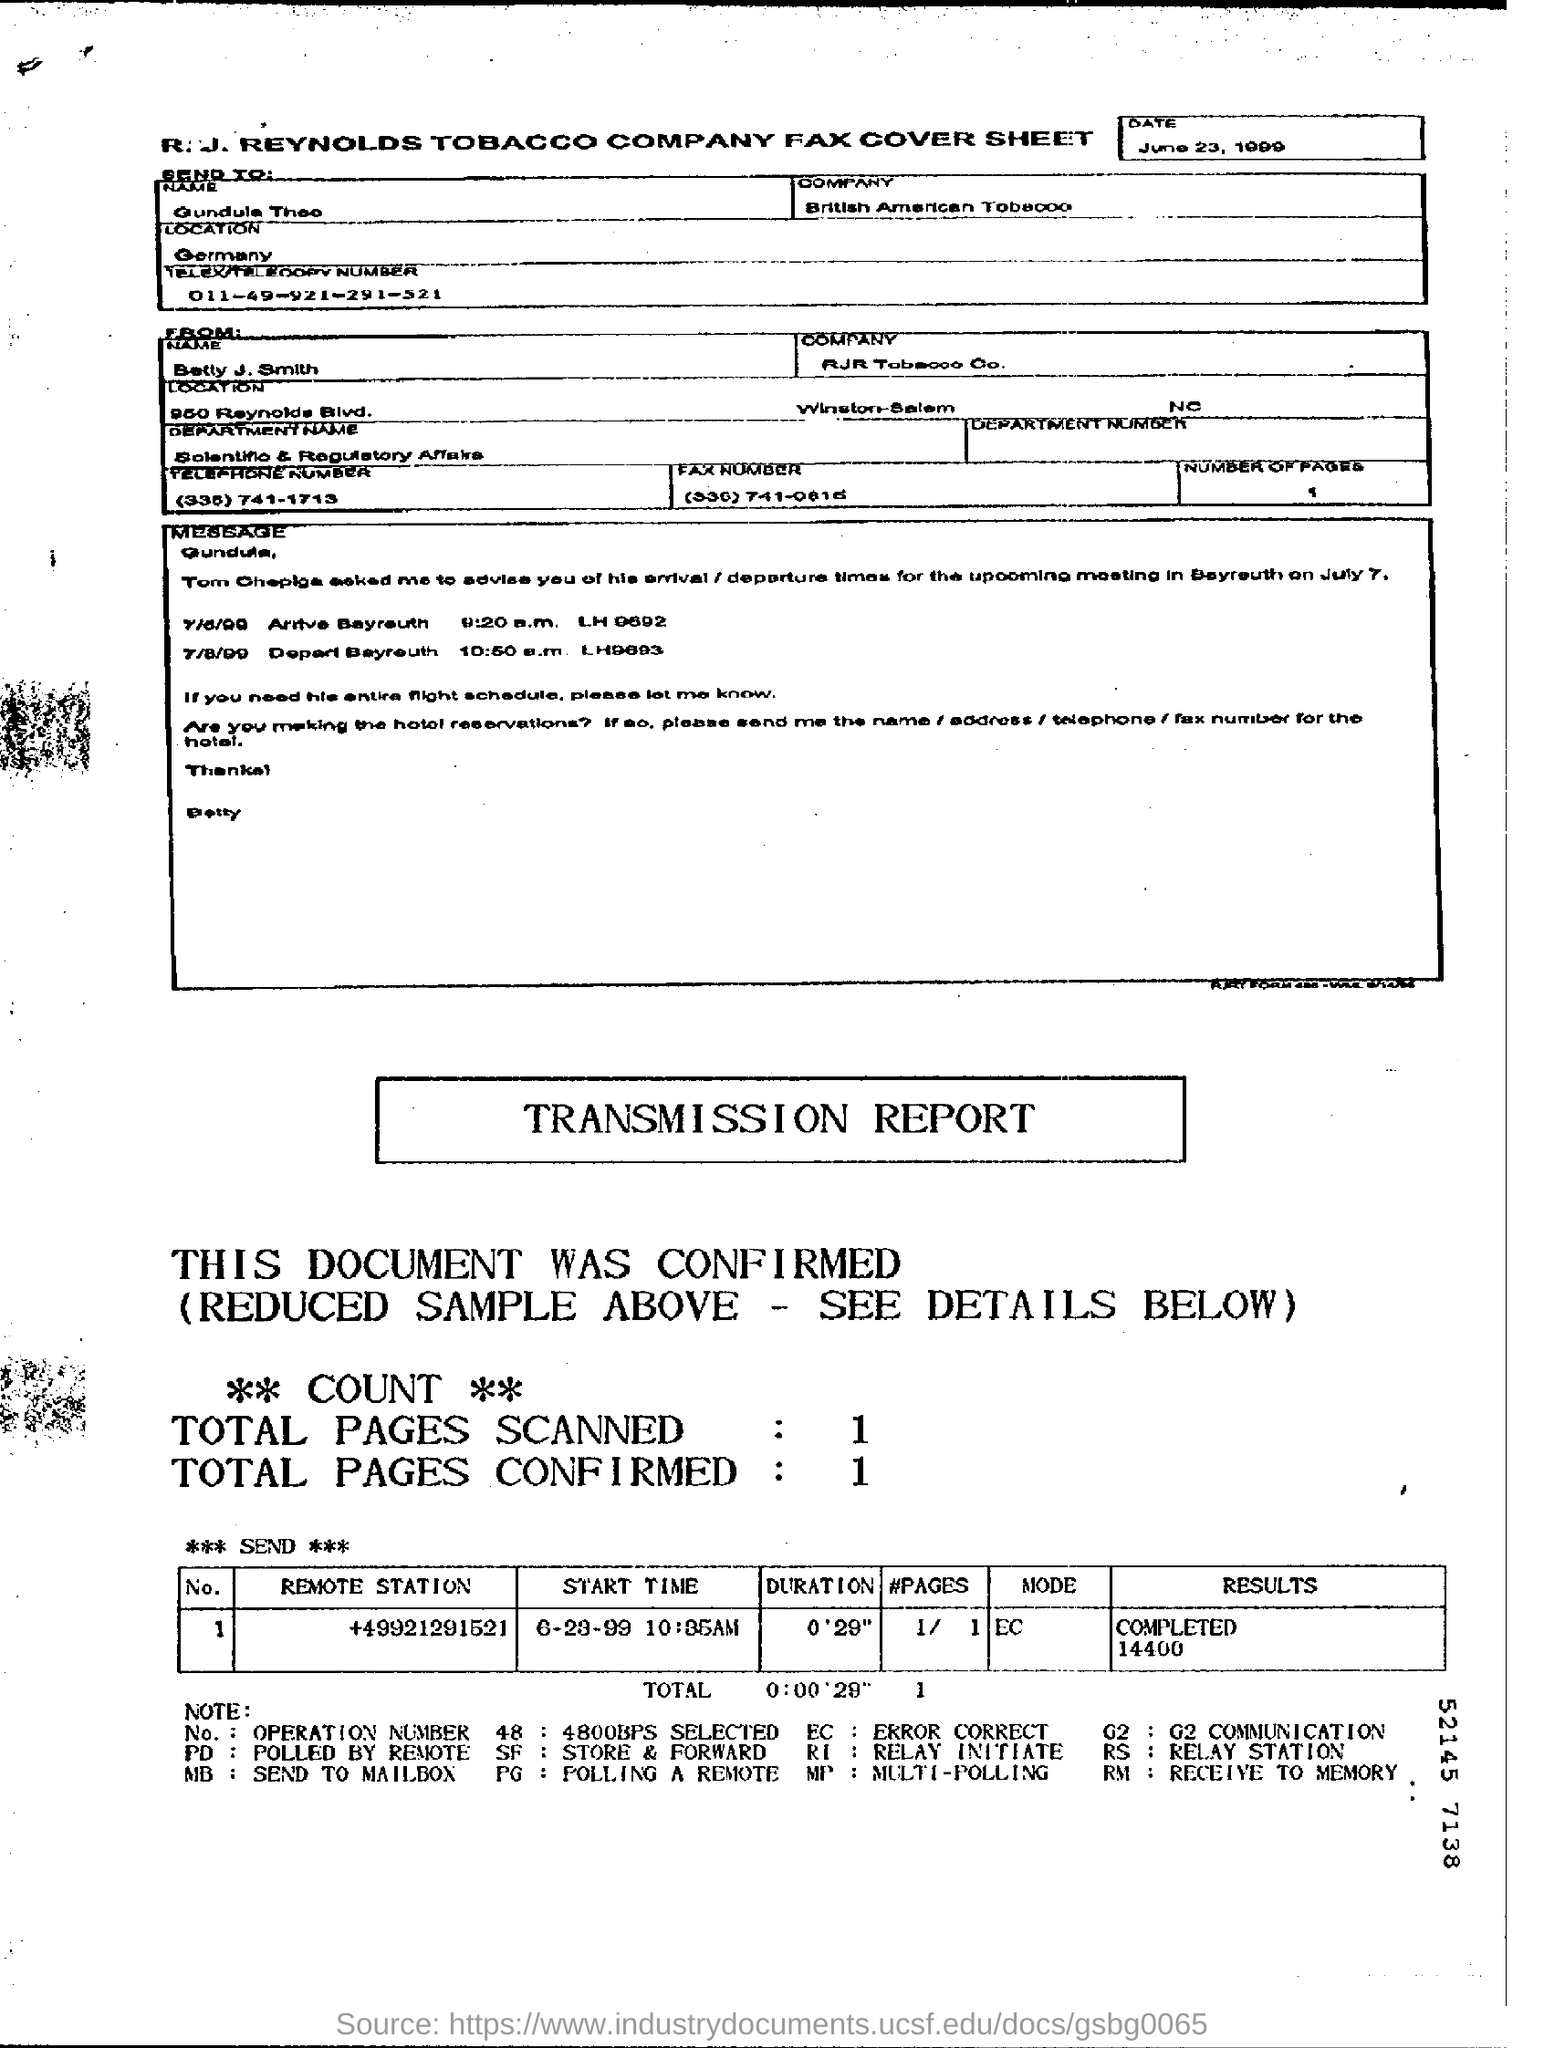To which company has the fax been sent?
Your answer should be very brief. British American Tobacco. When is the fax dated?
Your response must be concise. June 23, 1999. What does EC stand for?
Your answer should be very brief. Error Correct. 